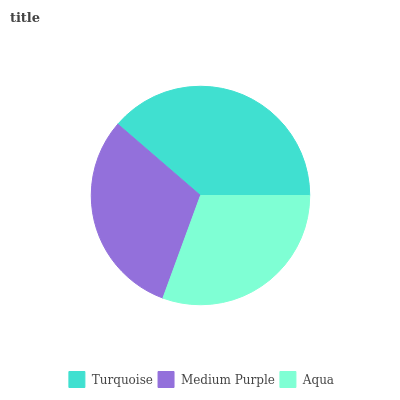Is Aqua the minimum?
Answer yes or no. Yes. Is Turquoise the maximum?
Answer yes or no. Yes. Is Medium Purple the minimum?
Answer yes or no. No. Is Medium Purple the maximum?
Answer yes or no. No. Is Turquoise greater than Medium Purple?
Answer yes or no. Yes. Is Medium Purple less than Turquoise?
Answer yes or no. Yes. Is Medium Purple greater than Turquoise?
Answer yes or no. No. Is Turquoise less than Medium Purple?
Answer yes or no. No. Is Medium Purple the high median?
Answer yes or no. Yes. Is Medium Purple the low median?
Answer yes or no. Yes. Is Aqua the high median?
Answer yes or no. No. Is Aqua the low median?
Answer yes or no. No. 